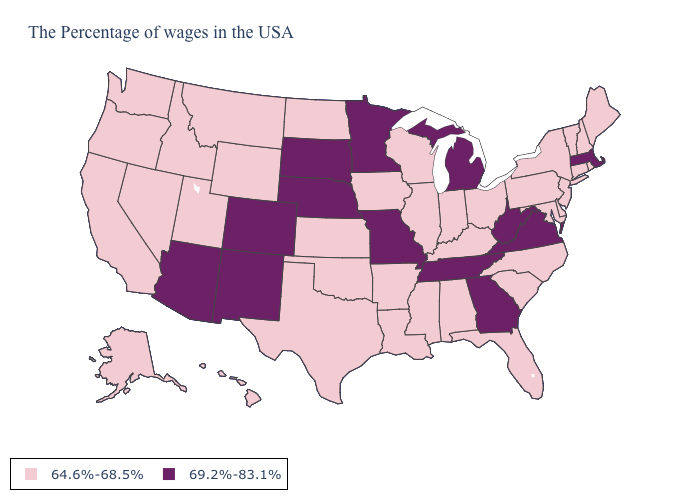Name the states that have a value in the range 64.6%-68.5%?
Short answer required. Maine, Rhode Island, New Hampshire, Vermont, Connecticut, New York, New Jersey, Delaware, Maryland, Pennsylvania, North Carolina, South Carolina, Ohio, Florida, Kentucky, Indiana, Alabama, Wisconsin, Illinois, Mississippi, Louisiana, Arkansas, Iowa, Kansas, Oklahoma, Texas, North Dakota, Wyoming, Utah, Montana, Idaho, Nevada, California, Washington, Oregon, Alaska, Hawaii. What is the highest value in the USA?
Be succinct. 69.2%-83.1%. Among the states that border Rhode Island , does Connecticut have the lowest value?
Give a very brief answer. Yes. What is the value of Louisiana?
Keep it brief. 64.6%-68.5%. Does New Mexico have the highest value in the West?
Keep it brief. Yes. What is the lowest value in the South?
Answer briefly. 64.6%-68.5%. Name the states that have a value in the range 69.2%-83.1%?
Answer briefly. Massachusetts, Virginia, West Virginia, Georgia, Michigan, Tennessee, Missouri, Minnesota, Nebraska, South Dakota, Colorado, New Mexico, Arizona. Name the states that have a value in the range 69.2%-83.1%?
Quick response, please. Massachusetts, Virginia, West Virginia, Georgia, Michigan, Tennessee, Missouri, Minnesota, Nebraska, South Dakota, Colorado, New Mexico, Arizona. Name the states that have a value in the range 69.2%-83.1%?
Be succinct. Massachusetts, Virginia, West Virginia, Georgia, Michigan, Tennessee, Missouri, Minnesota, Nebraska, South Dakota, Colorado, New Mexico, Arizona. Name the states that have a value in the range 64.6%-68.5%?
Short answer required. Maine, Rhode Island, New Hampshire, Vermont, Connecticut, New York, New Jersey, Delaware, Maryland, Pennsylvania, North Carolina, South Carolina, Ohio, Florida, Kentucky, Indiana, Alabama, Wisconsin, Illinois, Mississippi, Louisiana, Arkansas, Iowa, Kansas, Oklahoma, Texas, North Dakota, Wyoming, Utah, Montana, Idaho, Nevada, California, Washington, Oregon, Alaska, Hawaii. Name the states that have a value in the range 69.2%-83.1%?
Answer briefly. Massachusetts, Virginia, West Virginia, Georgia, Michigan, Tennessee, Missouri, Minnesota, Nebraska, South Dakota, Colorado, New Mexico, Arizona. What is the value of Rhode Island?
Concise answer only. 64.6%-68.5%. Does the first symbol in the legend represent the smallest category?
Keep it brief. Yes. Does Arizona have the highest value in the USA?
Write a very short answer. Yes. Name the states that have a value in the range 69.2%-83.1%?
Give a very brief answer. Massachusetts, Virginia, West Virginia, Georgia, Michigan, Tennessee, Missouri, Minnesota, Nebraska, South Dakota, Colorado, New Mexico, Arizona. 